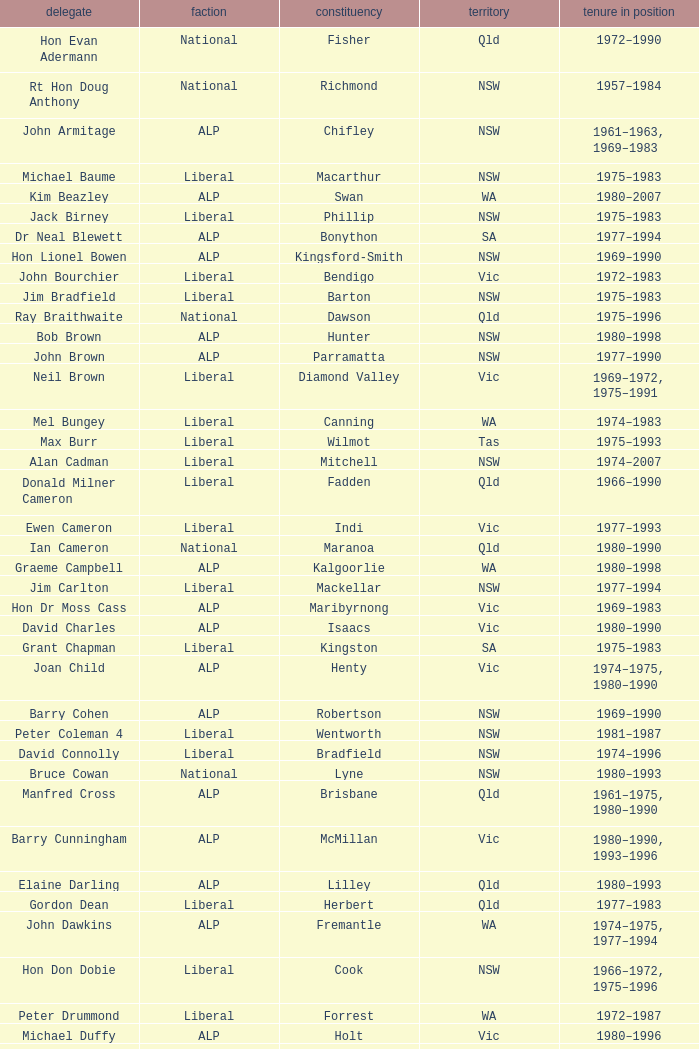To what party does Ralph Jacobi belong? ALP. Give me the full table as a dictionary. {'header': ['delegate', 'faction', 'constituency', 'territory', 'tenure in position'], 'rows': [['Hon Evan Adermann', 'National', 'Fisher', 'Qld', '1972–1990'], ['Rt Hon Doug Anthony', 'National', 'Richmond', 'NSW', '1957–1984'], ['John Armitage', 'ALP', 'Chifley', 'NSW', '1961–1963, 1969–1983'], ['Michael Baume', 'Liberal', 'Macarthur', 'NSW', '1975–1983'], ['Kim Beazley', 'ALP', 'Swan', 'WA', '1980–2007'], ['Jack Birney', 'Liberal', 'Phillip', 'NSW', '1975–1983'], ['Dr Neal Blewett', 'ALP', 'Bonython', 'SA', '1977–1994'], ['Hon Lionel Bowen', 'ALP', 'Kingsford-Smith', 'NSW', '1969–1990'], ['John Bourchier', 'Liberal', 'Bendigo', 'Vic', '1972–1983'], ['Jim Bradfield', 'Liberal', 'Barton', 'NSW', '1975–1983'], ['Ray Braithwaite', 'National', 'Dawson', 'Qld', '1975–1996'], ['Bob Brown', 'ALP', 'Hunter', 'NSW', '1980–1998'], ['John Brown', 'ALP', 'Parramatta', 'NSW', '1977–1990'], ['Neil Brown', 'Liberal', 'Diamond Valley', 'Vic', '1969–1972, 1975–1991'], ['Mel Bungey', 'Liberal', 'Canning', 'WA', '1974–1983'], ['Max Burr', 'Liberal', 'Wilmot', 'Tas', '1975–1993'], ['Alan Cadman', 'Liberal', 'Mitchell', 'NSW', '1974–2007'], ['Donald Milner Cameron', 'Liberal', 'Fadden', 'Qld', '1966–1990'], ['Ewen Cameron', 'Liberal', 'Indi', 'Vic', '1977–1993'], ['Ian Cameron', 'National', 'Maranoa', 'Qld', '1980–1990'], ['Graeme Campbell', 'ALP', 'Kalgoorlie', 'WA', '1980–1998'], ['Jim Carlton', 'Liberal', 'Mackellar', 'NSW', '1977–1994'], ['Hon Dr Moss Cass', 'ALP', 'Maribyrnong', 'Vic', '1969–1983'], ['David Charles', 'ALP', 'Isaacs', 'Vic', '1980–1990'], ['Grant Chapman', 'Liberal', 'Kingston', 'SA', '1975–1983'], ['Joan Child', 'ALP', 'Henty', 'Vic', '1974–1975, 1980–1990'], ['Barry Cohen', 'ALP', 'Robertson', 'NSW', '1969–1990'], ['Peter Coleman 4', 'Liberal', 'Wentworth', 'NSW', '1981–1987'], ['David Connolly', 'Liberal', 'Bradfield', 'NSW', '1974–1996'], ['Bruce Cowan', 'National', 'Lyne', 'NSW', '1980–1993'], ['Manfred Cross', 'ALP', 'Brisbane', 'Qld', '1961–1975, 1980–1990'], ['Barry Cunningham', 'ALP', 'McMillan', 'Vic', '1980–1990, 1993–1996'], ['Elaine Darling', 'ALP', 'Lilley', 'Qld', '1980–1993'], ['Gordon Dean', 'Liberal', 'Herbert', 'Qld', '1977–1983'], ['John Dawkins', 'ALP', 'Fremantle', 'WA', '1974–1975, 1977–1994'], ['Hon Don Dobie', 'Liberal', 'Cook', 'NSW', '1966–1972, 1975–1996'], ['Peter Drummond', 'Liberal', 'Forrest', 'WA', '1972–1987'], ['Michael Duffy', 'ALP', 'Holt', 'Vic', '1980–1996'], ['Dr Harry Edwards', 'Liberal', 'Berowra', 'NSW', '1972–1993'], ['Hon Robert Ellicott 4', 'Liberal', 'Wentworth', 'NSW', '1974–1981'], ['Hon Dr Doug Everingham', 'ALP', 'Capricornia', 'Qld', '1967–1975, 1977–1984'], ['Peter Falconer', 'Liberal', 'Casey', 'Vic', '1975–1983'], ['Hon Wal Fife', 'Liberal', 'Farrer', 'NSW', '1975–1993'], ['Peter Fisher', 'National', 'Mallee', 'Vic', '1972–1993'], ['Rt Hon Malcolm Fraser', 'Liberal', 'Wannon', 'Vic', '1955–1984'], ['Ross Free', 'ALP', 'Macquarie', 'NSW', '1980–1996'], ['Ken Fry', 'ALP', 'Fraser', 'ACT', '1974–1984'], ['Hon Victor Garland 3', 'Liberal', 'Curtin', 'WA', '1969–1981'], ['Geoffrey Giles', 'Liberal', 'Wakefield', 'SA', '1964–1983'], ['Bruce Goodluck', 'Liberal', 'Franklin', 'Tas', '1975–1993'], ['Hon Ray Groom', 'Liberal', 'Braddon', 'Tas', '1975–1984'], ['Steele Hall 2', 'Liberal', 'Boothby', 'SA', '1981–1996'], ['Graham Harris', 'Liberal', 'Chisholm', 'Vic', '1980–1983'], ['Bob Hawke', 'ALP', 'Wills', 'Vic', '1980–1992'], ['Hon Bill Hayden', 'ALP', 'Oxley', 'Qld', '1961–1988'], ['Noel Hicks', 'National', 'Riverina', 'NSW', '1980–1998'], ['John Hodges', 'Liberal', 'Petrie', 'Qld', '1974–1983, 1984–1987'], ['Michael Hodgman', 'Liberal', 'Denison', 'Tas', '1975–1987'], ['Clyde Holding', 'ALP', 'Melbourne Ports', 'Vic', '1977–1998'], ['Hon John Howard', 'Liberal', 'Bennelong', 'NSW', '1974–2007'], ['Brian Howe', 'ALP', 'Batman', 'Vic', '1977–1996'], ['Ben Humphreys', 'ALP', 'Griffith', 'Qld', '1977–1996'], ['Hon Ralph Hunt', 'National', 'Gwydir', 'NSW', '1969–1989'], ['Chris Hurford', 'ALP', 'Adelaide', 'SA', '1969–1988'], ['John Hyde', 'Liberal', 'Moore', 'WA', '1974–1983'], ['Ted Innes', 'ALP', 'Melbourne', 'Vic', '1972–1983'], ['Ralph Jacobi', 'ALP', 'Hawker', 'SA', '1969–1987'], ['Alan Jarman', 'Liberal', 'Deakin', 'Vic', '1966–1983'], ['Dr Harry Jenkins', 'ALP', 'Scullin', 'Vic', '1969–1985'], ['Hon Les Johnson', 'ALP', 'Hughes', 'NSW', '1955–1966, 1969–1984'], ['Barry Jones', 'ALP', 'Lalor', 'Vic', '1977–1998'], ['Hon Charles Jones', 'ALP', 'Newcastle', 'NSW', '1958–1983'], ['David Jull', 'Liberal', 'Bowman', 'Qld', '1975–1983, 1984–2007'], ['Hon Bob Katter', 'National', 'Kennedy', 'Qld', '1966–1990'], ['Hon Paul Keating', 'ALP', 'Blaxland', 'NSW', '1969–1996'], ['Ros Kelly', 'ALP', 'Canberra', 'ACT', '1980–1995'], ['Lewis Kent', 'ALP', 'Hotham', 'Vic', '1980–1990'], ['John Kerin', 'ALP', 'Werriwa', 'NSW', '1972–1975, 1978–1994'], ['Hon Jim Killen', 'Liberal', 'Moreton', 'Qld', '1955–1983'], ['Dr Dick Klugman', 'ALP', 'Prospect', 'NSW', '1969–1990'], ['Bruce Lloyd', 'National', 'Murray', 'Vic', '1971–1996'], ['Stephen Lusher', 'National', 'Hume', 'NSW', '1974–1984'], ['Rt Hon Phillip Lynch 6', 'Liberal', 'Flinders', 'Vic', '1966–1982'], ['Hon Michael MacKellar', 'Liberal', 'Warringah', 'NSW', '1969–1994'], ['Sandy Mackenzie', 'National', 'Calare', 'NSW', '1975–1983'], ['Hon Ian Macphee', 'Liberal', 'Balaclava', 'Vic', '1974–1990'], ['Michael Maher 5', 'ALP', 'Lowe', 'NSW', '1982–1987'], ['Ross McLean', 'Liberal', 'Perth', 'WA', '1975–1983'], ['Hon John McLeay 2', 'Liberal', 'Boothby', 'SA', '1966–1981'], ['Leo McLeay', 'ALP', 'Grayndler', 'NSW', '1979–2004'], ['Leslie McMahon', 'ALP', 'Sydney', 'NSW', '1975–1983'], ['Rt Hon Sir William McMahon 5', 'Liberal', 'Lowe', 'NSW', '1949–1981'], ['Tom McVeigh', 'National', 'Darling Downs', 'Qld', '1972–1988'], ['John Mildren', 'ALP', 'Ballarat', 'Vic', '1980–1990'], ['Clarrie Millar', 'National', 'Wide Bay', 'Qld', '1974–1990'], ['Peter Milton', 'ALP', 'La Trobe', 'Vic', '1980–1990'], ['John Moore', 'Liberal', 'Ryan', 'Qld', '1975–2001'], ['Peter Morris', 'ALP', 'Shortland', 'NSW', '1972–1998'], ['Hon Bill Morrison', 'ALP', 'St George', 'NSW', '1969–1975, 1980–1984'], ['John Mountford', 'ALP', 'Banks', 'NSW', '1980–1990'], ['Hon Kevin Newman', 'Liberal', 'Bass', 'Tas', '1975–1984'], ['Hon Peter Nixon', 'National', 'Gippsland', 'Vic', '1961–1983'], ["Frank O'Keefe", 'National', 'Paterson', 'NSW', '1969–1984'], ['Hon Andrew Peacock', 'Liberal', 'Kooyong', 'Vic', '1966–1994'], ['James Porter', 'Liberal', 'Barker', 'SA', '1975–1990'], ['Peter Reith 6', 'Liberal', 'Flinders', 'Vic', '1982–1983, 1984–2001'], ['Hon Eric Robinson 1', 'Liberal', 'McPherson', 'Qld', '1972–1990'], ['Hon Ian Robinson', 'National', 'Cowper', 'NSW', '1963–1981'], ['Allan Rocher 3', 'Liberal', 'Curtin', 'WA', '1981–1998'], ['Philip Ruddock', 'Liberal', 'Dundas', 'NSW', '1973–present'], ['Murray Sainsbury', 'Liberal', 'Eden-Monaro', 'NSW', '1975–1983'], ['Hon Gordon Scholes', 'ALP', 'Corio', 'Vic', '1967–1993'], ['John Scott', 'ALP', 'Hindmarsh', 'SA', '1980–1993'], ['Peter Shack', 'Liberal', 'Tangney', 'WA', '1977–1983, 1984–1993'], ['Roger Shipton', 'Liberal', 'Higgins', 'Vic', '1975–1990'], ['Rt Hon Ian Sinclair', 'National', 'New England', 'NSW', '1963–1998'], ['Rt Hon Sir Billy Snedden', 'Liberal', 'Bruce', 'Vic', '1955–1983'], ['John Spender', 'Liberal', 'North Sydney', 'NSW', '1980–1990'], ['Hon Tony Street', 'Liberal', 'Corangamite', 'Vic', '1966–1984'], ['Grant Tambling', 'CLP', 'Northern Territory', 'NT', '1980–1983'], ['Dr Andrew Theophanous', 'ALP', 'Burke', 'Vic', '1980–2001'], ['Hon David Thomson', 'National', 'Leichhardt', 'Qld', '1975–1983'], ['Wilson Tuckey', 'Liberal', "O'Connor", 'WA', '1980–2010'], ['Hon Tom Uren', 'ALP', 'Reid', 'NSW', '1958–1990'], ['Hon Ian Viner', 'Liberal', 'Stirling', 'WA', '1972–1983'], ['Laurie Wallis', 'ALP', 'Grey', 'SA', '1969–1983'], ['Stewart West', 'ALP', 'Cunningham', 'NSW', '1977–1993'], ['Peter White 1', 'Liberal', 'McPherson', 'Qld', '1981–1990'], ['Ralph Willis', 'ALP', 'Gellibrand', 'Vic', '1972–1998'], ['Ian Wilson', 'Liberal', 'Sturt', 'SA', '1966–1969, 1972–1993'], ['Mick Young', 'ALP', 'Port Adelaide', 'SA', '1974–1988']]} 